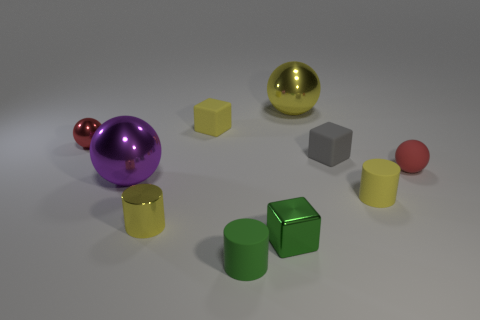Is there a big red sphere?
Provide a succinct answer. No. What material is the large object that is behind the red ball to the right of the yellow cylinder to the right of the big yellow shiny object made of?
Offer a terse response. Metal. There is a big purple thing; does it have the same shape as the tiny yellow object that is behind the red metallic object?
Your response must be concise. No. How many red objects are the same shape as the purple shiny thing?
Make the answer very short. 2. What is the shape of the small gray thing?
Offer a very short reply. Cube. There is a shiny ball that is behind the tiny red thing on the left side of the large yellow metal object; how big is it?
Keep it short and to the point. Large. What number of things are shiny spheres or brown metallic things?
Make the answer very short. 3. Is the purple shiny object the same shape as the big yellow metallic thing?
Your response must be concise. Yes. Are there any large gray spheres that have the same material as the small gray object?
Your response must be concise. No. There is a tiny ball that is left of the purple object; is there a small rubber block that is left of it?
Your response must be concise. No. 